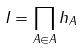<formula> <loc_0><loc_0><loc_500><loc_500>I = \prod _ { A \in A } h _ { A }</formula> 